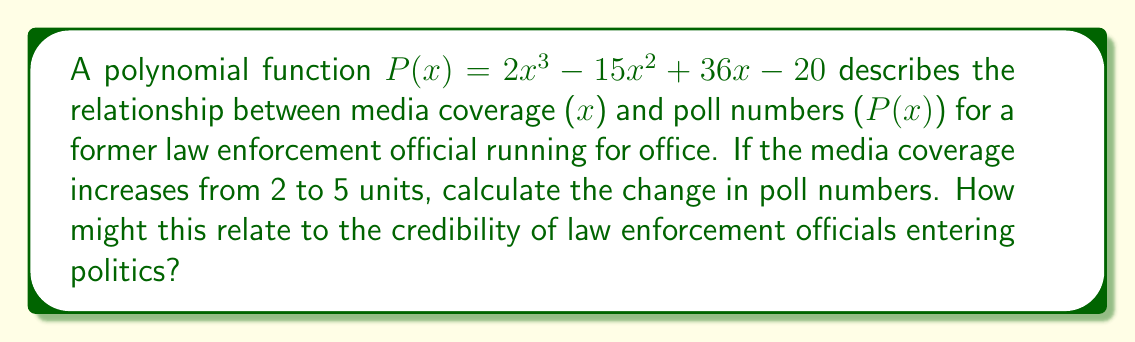Provide a solution to this math problem. To solve this problem, we need to evaluate the polynomial function at x = 2 and x = 5, then find the difference:

1. Evaluate P(2):
   $P(2) = 2(2)^3 - 15(2)^2 + 36(2) - 20$
   $= 2(8) - 15(4) + 36(2) - 20$
   $= 16 - 60 + 72 - 20$
   $= 8$

2. Evaluate P(5):
   $P(5) = 2(5)^3 - 15(5)^2 + 36(5) - 20$
   $= 2(125) - 15(25) + 36(5) - 20$
   $= 250 - 375 + 180 - 20$
   $= 35$

3. Calculate the change in poll numbers:
   Change = P(5) - P(2) = 35 - 8 = 27

This significant increase in poll numbers with increased media coverage might suggest that the public's perception of law enforcement officials in politics is heavily influenced by media exposure, potentially raising questions about the true qualifications and credibility of such candidates.
Answer: 27 